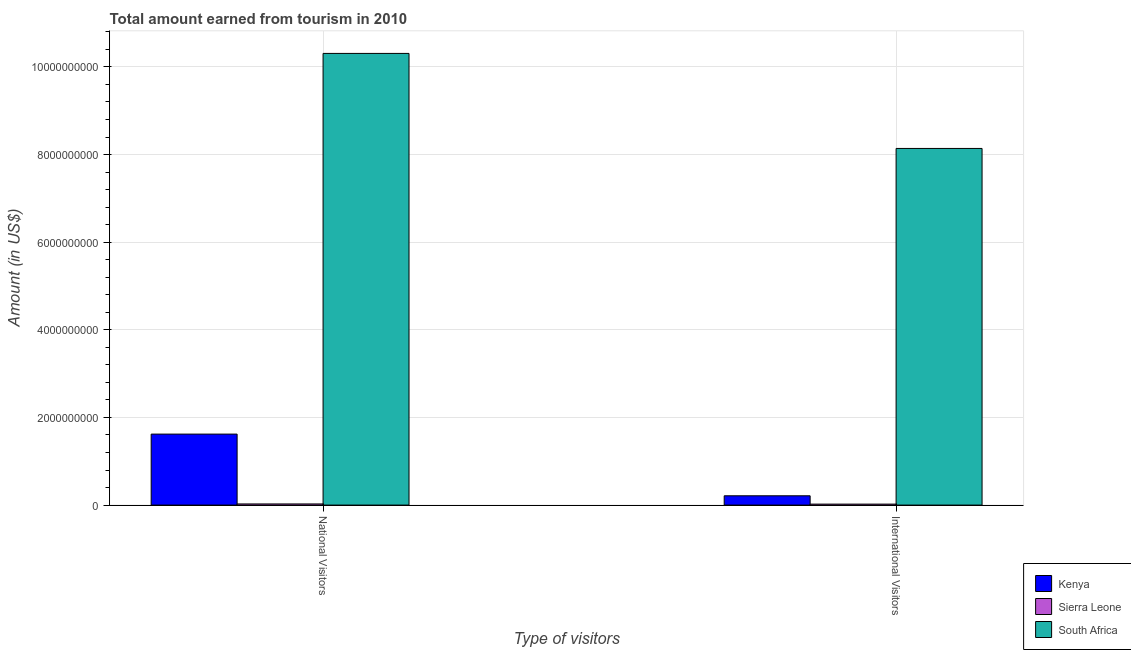Are the number of bars per tick equal to the number of legend labels?
Provide a short and direct response. Yes. What is the label of the 2nd group of bars from the left?
Your answer should be compact. International Visitors. What is the amount earned from national visitors in Kenya?
Provide a short and direct response. 1.62e+09. Across all countries, what is the maximum amount earned from international visitors?
Ensure brevity in your answer.  8.14e+09. Across all countries, what is the minimum amount earned from international visitors?
Your answer should be very brief. 2.20e+07. In which country was the amount earned from national visitors maximum?
Provide a short and direct response. South Africa. In which country was the amount earned from national visitors minimum?
Give a very brief answer. Sierra Leone. What is the total amount earned from international visitors in the graph?
Your response must be concise. 8.37e+09. What is the difference between the amount earned from national visitors in Kenya and that in South Africa?
Make the answer very short. -8.69e+09. What is the difference between the amount earned from national visitors in Kenya and the amount earned from international visitors in Sierra Leone?
Give a very brief answer. 1.60e+09. What is the average amount earned from national visitors per country?
Ensure brevity in your answer.  3.98e+09. What is the difference between the amount earned from national visitors and amount earned from international visitors in South Africa?
Offer a terse response. 2.17e+09. In how many countries, is the amount earned from national visitors greater than 7200000000 US$?
Provide a succinct answer. 1. What is the ratio of the amount earned from national visitors in South Africa to that in Sierra Leone?
Make the answer very short. 396.46. Is the amount earned from national visitors in Kenya less than that in South Africa?
Give a very brief answer. Yes. In how many countries, is the amount earned from international visitors greater than the average amount earned from international visitors taken over all countries?
Give a very brief answer. 1. What does the 1st bar from the left in National Visitors represents?
Ensure brevity in your answer.  Kenya. What does the 1st bar from the right in International Visitors represents?
Give a very brief answer. South Africa. How many bars are there?
Provide a succinct answer. 6. What is the difference between two consecutive major ticks on the Y-axis?
Offer a terse response. 2.00e+09. Are the values on the major ticks of Y-axis written in scientific E-notation?
Ensure brevity in your answer.  No. What is the title of the graph?
Provide a succinct answer. Total amount earned from tourism in 2010. Does "Montenegro" appear as one of the legend labels in the graph?
Give a very brief answer. No. What is the label or title of the X-axis?
Your response must be concise. Type of visitors. What is the label or title of the Y-axis?
Your answer should be compact. Amount (in US$). What is the Amount (in US$) in Kenya in National Visitors?
Provide a short and direct response. 1.62e+09. What is the Amount (in US$) of Sierra Leone in National Visitors?
Your answer should be very brief. 2.60e+07. What is the Amount (in US$) of South Africa in National Visitors?
Provide a succinct answer. 1.03e+1. What is the Amount (in US$) of Kenya in International Visitors?
Give a very brief answer. 2.12e+08. What is the Amount (in US$) of Sierra Leone in International Visitors?
Ensure brevity in your answer.  2.20e+07. What is the Amount (in US$) in South Africa in International Visitors?
Keep it short and to the point. 8.14e+09. Across all Type of visitors, what is the maximum Amount (in US$) of Kenya?
Offer a terse response. 1.62e+09. Across all Type of visitors, what is the maximum Amount (in US$) in Sierra Leone?
Offer a terse response. 2.60e+07. Across all Type of visitors, what is the maximum Amount (in US$) of South Africa?
Your answer should be compact. 1.03e+1. Across all Type of visitors, what is the minimum Amount (in US$) in Kenya?
Offer a terse response. 2.12e+08. Across all Type of visitors, what is the minimum Amount (in US$) of Sierra Leone?
Your answer should be compact. 2.20e+07. Across all Type of visitors, what is the minimum Amount (in US$) of South Africa?
Keep it short and to the point. 8.14e+09. What is the total Amount (in US$) of Kenya in the graph?
Give a very brief answer. 1.83e+09. What is the total Amount (in US$) in Sierra Leone in the graph?
Offer a very short reply. 4.80e+07. What is the total Amount (in US$) of South Africa in the graph?
Provide a succinct answer. 1.84e+1. What is the difference between the Amount (in US$) of Kenya in National Visitors and that in International Visitors?
Provide a succinct answer. 1.41e+09. What is the difference between the Amount (in US$) in Sierra Leone in National Visitors and that in International Visitors?
Offer a very short reply. 4.00e+06. What is the difference between the Amount (in US$) in South Africa in National Visitors and that in International Visitors?
Provide a succinct answer. 2.17e+09. What is the difference between the Amount (in US$) of Kenya in National Visitors and the Amount (in US$) of Sierra Leone in International Visitors?
Give a very brief answer. 1.60e+09. What is the difference between the Amount (in US$) in Kenya in National Visitors and the Amount (in US$) in South Africa in International Visitors?
Provide a succinct answer. -6.52e+09. What is the difference between the Amount (in US$) in Sierra Leone in National Visitors and the Amount (in US$) in South Africa in International Visitors?
Provide a short and direct response. -8.11e+09. What is the average Amount (in US$) in Kenya per Type of visitors?
Offer a terse response. 9.16e+08. What is the average Amount (in US$) in Sierra Leone per Type of visitors?
Give a very brief answer. 2.40e+07. What is the average Amount (in US$) in South Africa per Type of visitors?
Your answer should be compact. 9.22e+09. What is the difference between the Amount (in US$) in Kenya and Amount (in US$) in Sierra Leone in National Visitors?
Offer a very short reply. 1.59e+09. What is the difference between the Amount (in US$) in Kenya and Amount (in US$) in South Africa in National Visitors?
Your answer should be compact. -8.69e+09. What is the difference between the Amount (in US$) in Sierra Leone and Amount (in US$) in South Africa in National Visitors?
Ensure brevity in your answer.  -1.03e+1. What is the difference between the Amount (in US$) of Kenya and Amount (in US$) of Sierra Leone in International Visitors?
Make the answer very short. 1.90e+08. What is the difference between the Amount (in US$) of Kenya and Amount (in US$) of South Africa in International Visitors?
Ensure brevity in your answer.  -7.93e+09. What is the difference between the Amount (in US$) of Sierra Leone and Amount (in US$) of South Africa in International Visitors?
Provide a short and direct response. -8.12e+09. What is the ratio of the Amount (in US$) of Kenya in National Visitors to that in International Visitors?
Offer a very short reply. 7.64. What is the ratio of the Amount (in US$) in Sierra Leone in National Visitors to that in International Visitors?
Keep it short and to the point. 1.18. What is the ratio of the Amount (in US$) in South Africa in National Visitors to that in International Visitors?
Offer a very short reply. 1.27. What is the difference between the highest and the second highest Amount (in US$) of Kenya?
Your answer should be compact. 1.41e+09. What is the difference between the highest and the second highest Amount (in US$) of South Africa?
Keep it short and to the point. 2.17e+09. What is the difference between the highest and the lowest Amount (in US$) of Kenya?
Provide a short and direct response. 1.41e+09. What is the difference between the highest and the lowest Amount (in US$) in South Africa?
Ensure brevity in your answer.  2.17e+09. 